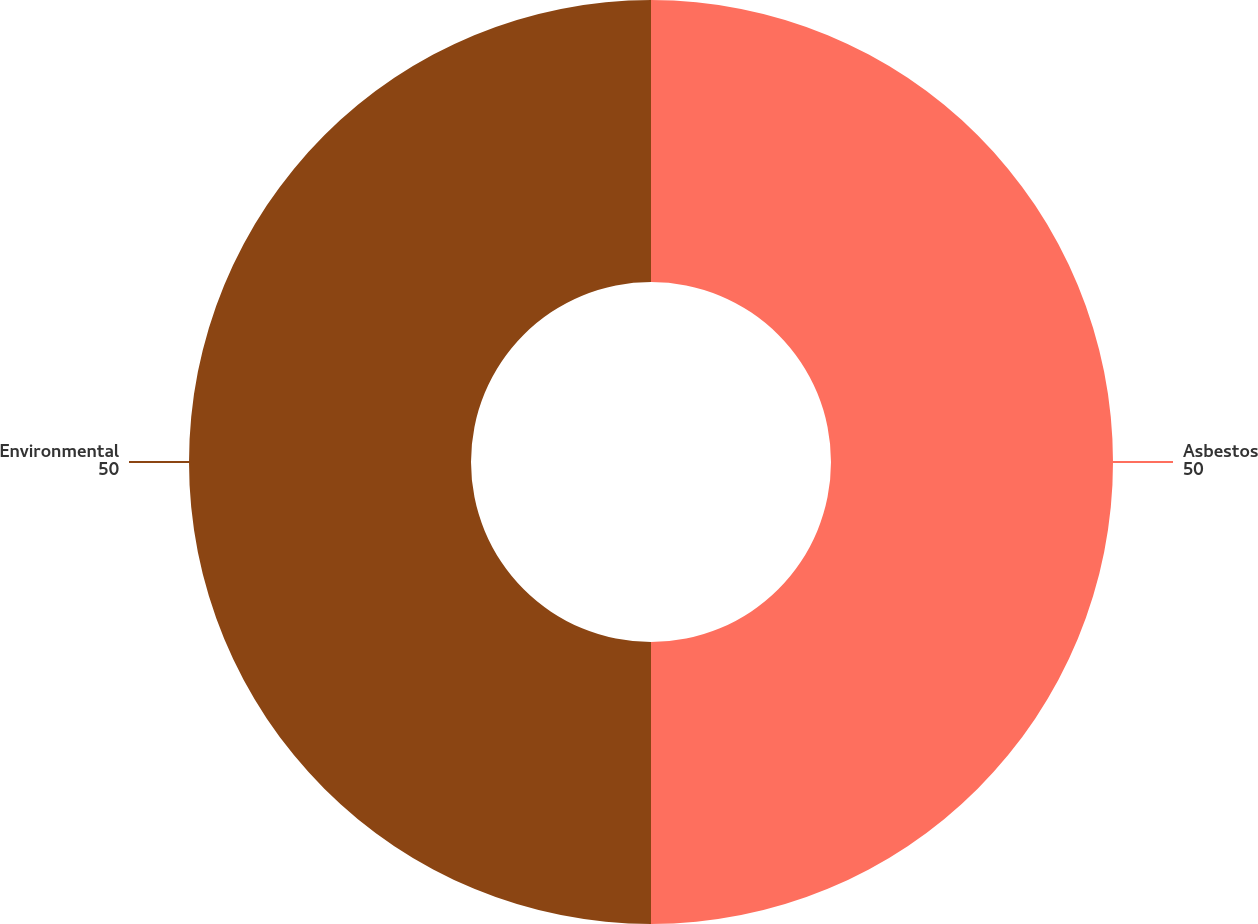<chart> <loc_0><loc_0><loc_500><loc_500><pie_chart><fcel>Asbestos<fcel>Environmental<nl><fcel>50.0%<fcel>50.0%<nl></chart> 